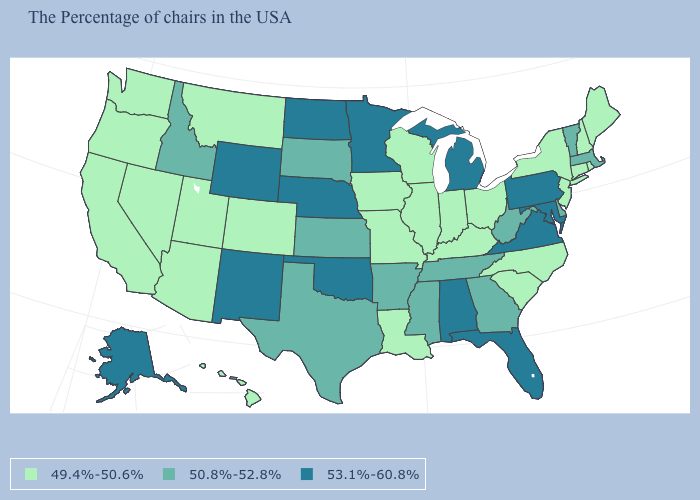Among the states that border Rhode Island , does Connecticut have the lowest value?
Concise answer only. Yes. Among the states that border Maryland , which have the highest value?
Concise answer only. Pennsylvania, Virginia. What is the value of Nebraska?
Give a very brief answer. 53.1%-60.8%. What is the value of North Carolina?
Keep it brief. 49.4%-50.6%. Which states have the highest value in the USA?
Give a very brief answer. Maryland, Pennsylvania, Virginia, Florida, Michigan, Alabama, Minnesota, Nebraska, Oklahoma, North Dakota, Wyoming, New Mexico, Alaska. Name the states that have a value in the range 50.8%-52.8%?
Short answer required. Massachusetts, Vermont, Delaware, West Virginia, Georgia, Tennessee, Mississippi, Arkansas, Kansas, Texas, South Dakota, Idaho. Does Iowa have the highest value in the USA?
Concise answer only. No. What is the lowest value in the USA?
Give a very brief answer. 49.4%-50.6%. What is the highest value in states that border Connecticut?
Answer briefly. 50.8%-52.8%. Which states have the lowest value in the USA?
Give a very brief answer. Maine, Rhode Island, New Hampshire, Connecticut, New York, New Jersey, North Carolina, South Carolina, Ohio, Kentucky, Indiana, Wisconsin, Illinois, Louisiana, Missouri, Iowa, Colorado, Utah, Montana, Arizona, Nevada, California, Washington, Oregon, Hawaii. Is the legend a continuous bar?
Give a very brief answer. No. Name the states that have a value in the range 50.8%-52.8%?
Keep it brief. Massachusetts, Vermont, Delaware, West Virginia, Georgia, Tennessee, Mississippi, Arkansas, Kansas, Texas, South Dakota, Idaho. Name the states that have a value in the range 50.8%-52.8%?
Answer briefly. Massachusetts, Vermont, Delaware, West Virginia, Georgia, Tennessee, Mississippi, Arkansas, Kansas, Texas, South Dakota, Idaho. Name the states that have a value in the range 50.8%-52.8%?
Concise answer only. Massachusetts, Vermont, Delaware, West Virginia, Georgia, Tennessee, Mississippi, Arkansas, Kansas, Texas, South Dakota, Idaho. 